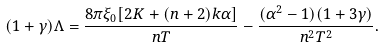<formula> <loc_0><loc_0><loc_500><loc_500>( 1 + \gamma ) \Lambda = \frac { 8 \pi \xi _ { 0 } [ 2 K + ( n + 2 ) k \alpha ] } { n T } - \frac { ( \alpha ^ { 2 } - 1 ) ( 1 + 3 \gamma ) } { n ^ { 2 } T ^ { 2 } } .</formula> 